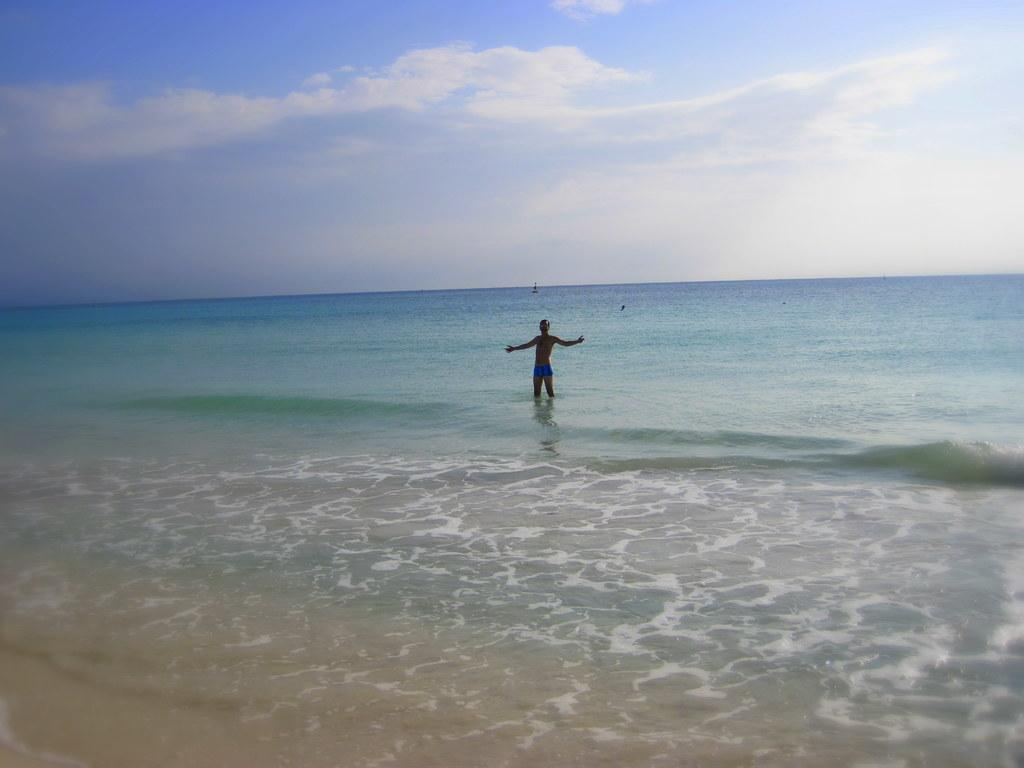Where was the image taken? The image was taken at a beach. What can be seen in the middle of the image? There is water in the middle of the image. Can you describe the person in the image? There is one person standing in the water. What is visible at the top of the image? The sky is visible at the top of the image. What type of zipper can be seen on the person's clothing in the image? There is no zipper visible on the person's clothing in the image. What memory does the person in the image have about their childhood at the beach? The image does not provide any information about the person's memories or experiences, so we cannot determine their childhood memories at the beach. 